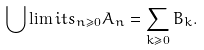<formula> <loc_0><loc_0><loc_500><loc_500>\bigcup \lim i t s _ { n \geq 0 } A _ { n } = \sum _ { k \geq 0 } B _ { k } .</formula> 